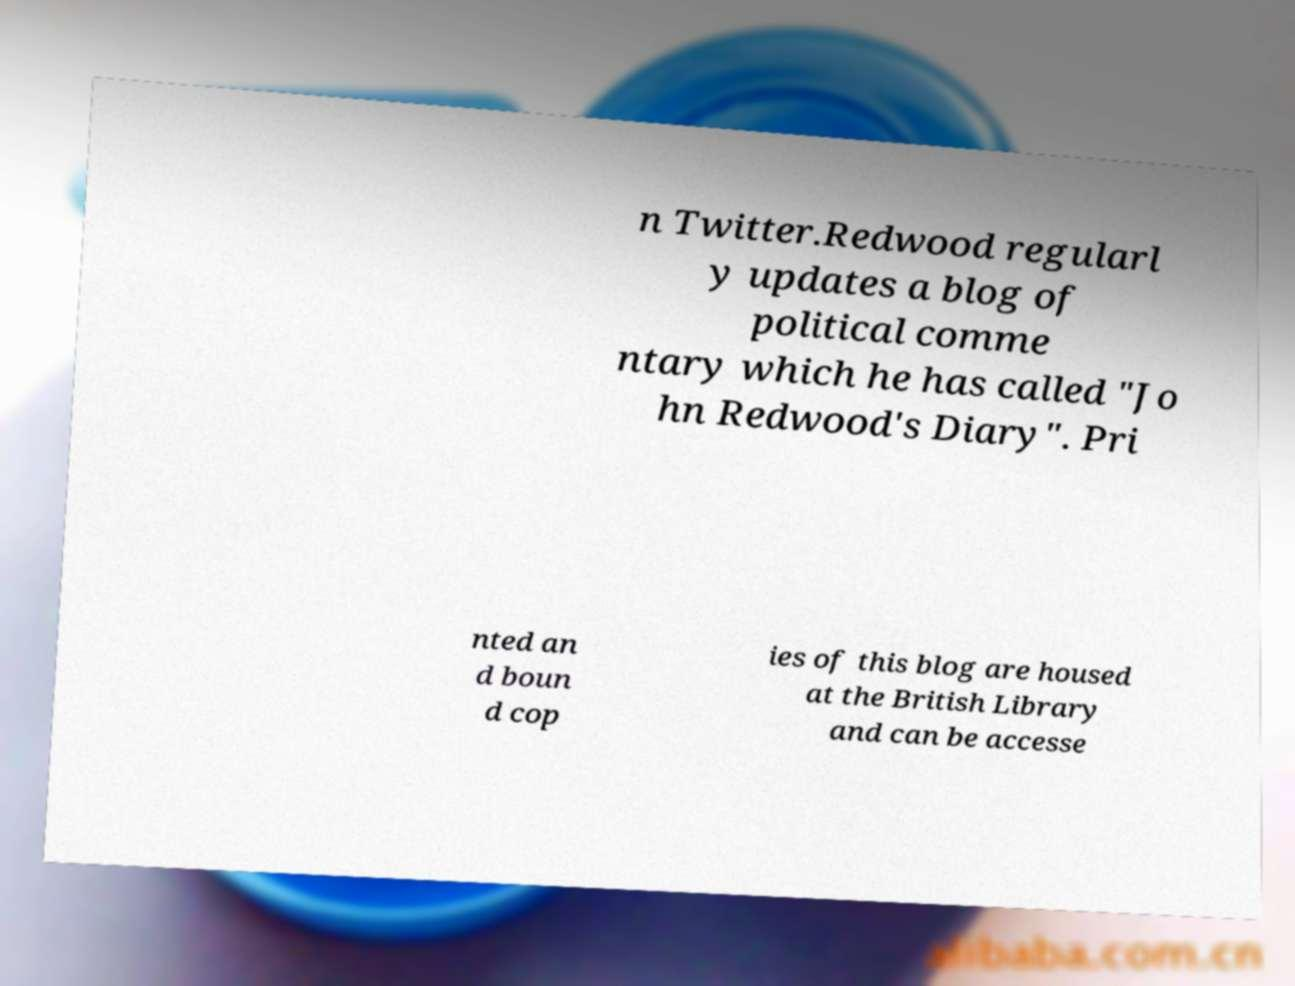Can you read and provide the text displayed in the image?This photo seems to have some interesting text. Can you extract and type it out for me? n Twitter.Redwood regularl y updates a blog of political comme ntary which he has called "Jo hn Redwood's Diary". Pri nted an d boun d cop ies of this blog are housed at the British Library and can be accesse 